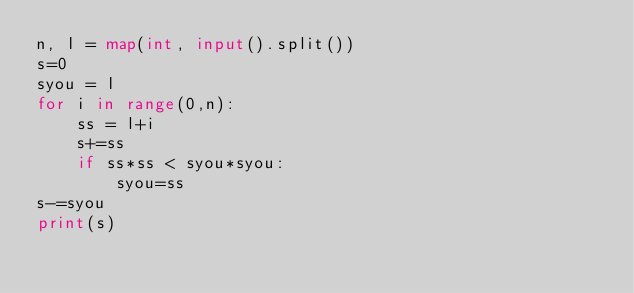<code> <loc_0><loc_0><loc_500><loc_500><_Python_>n, l = map(int, input().split())
s=0
syou = l
for i in range(0,n):
    ss = l+i
    s+=ss
    if ss*ss < syou*syou:
        syou=ss
s-=syou
print(s)</code> 